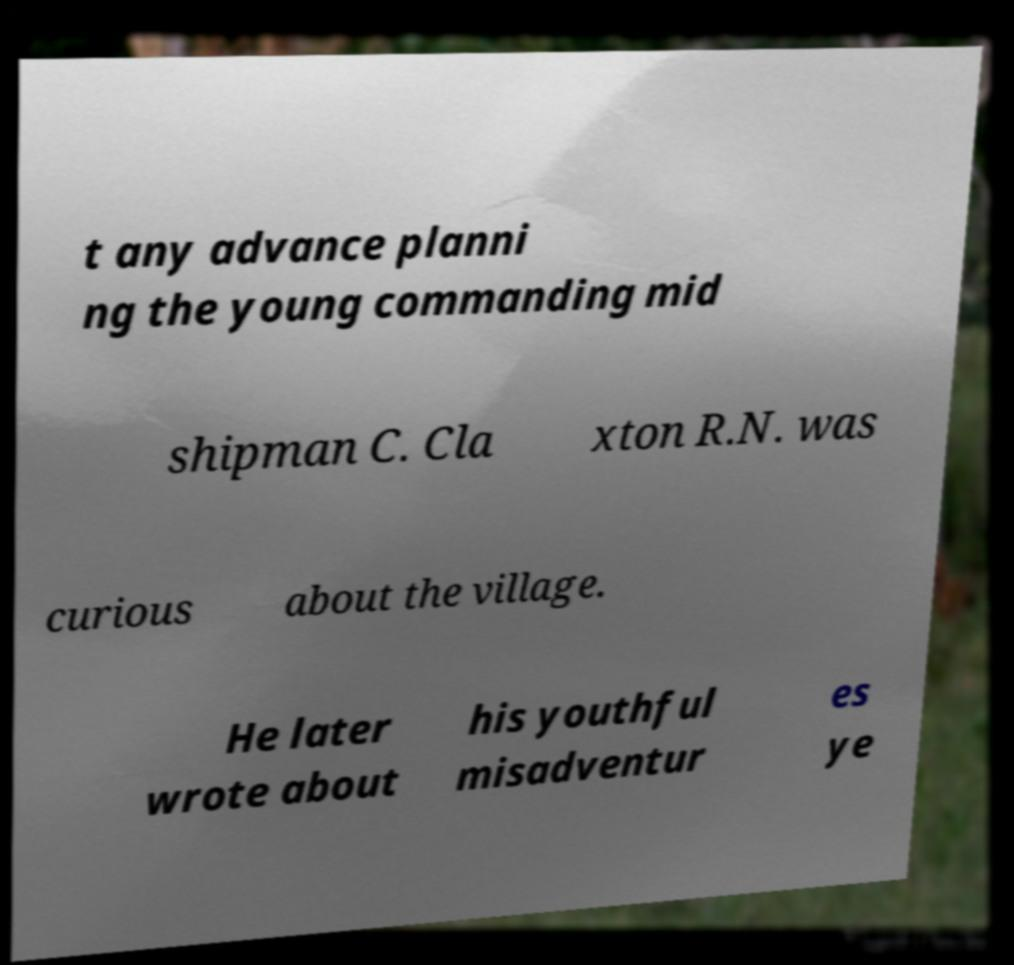For documentation purposes, I need the text within this image transcribed. Could you provide that? t any advance planni ng the young commanding mid shipman C. Cla xton R.N. was curious about the village. He later wrote about his youthful misadventur es ye 